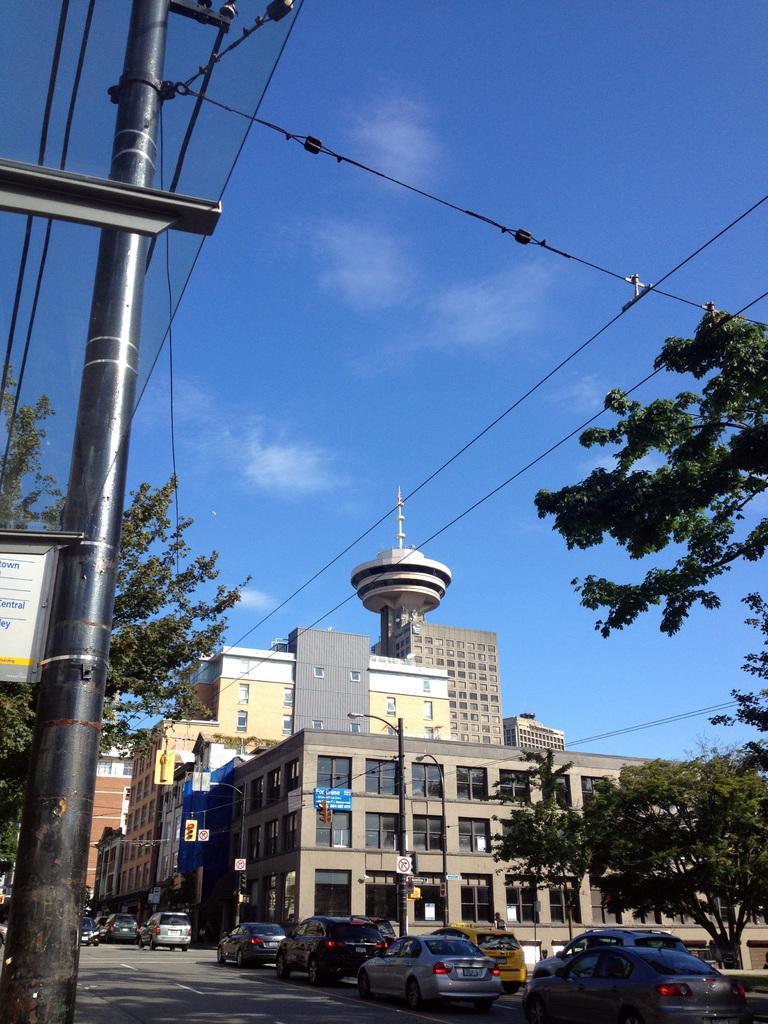Please provide a concise description of this image. This picture is clicked outside. On the left we can see a pole and a board attached to the pole. On the right we can see the buildings, trees, group of vehicles running on the road. In the background there is a sky, cables and trees. 